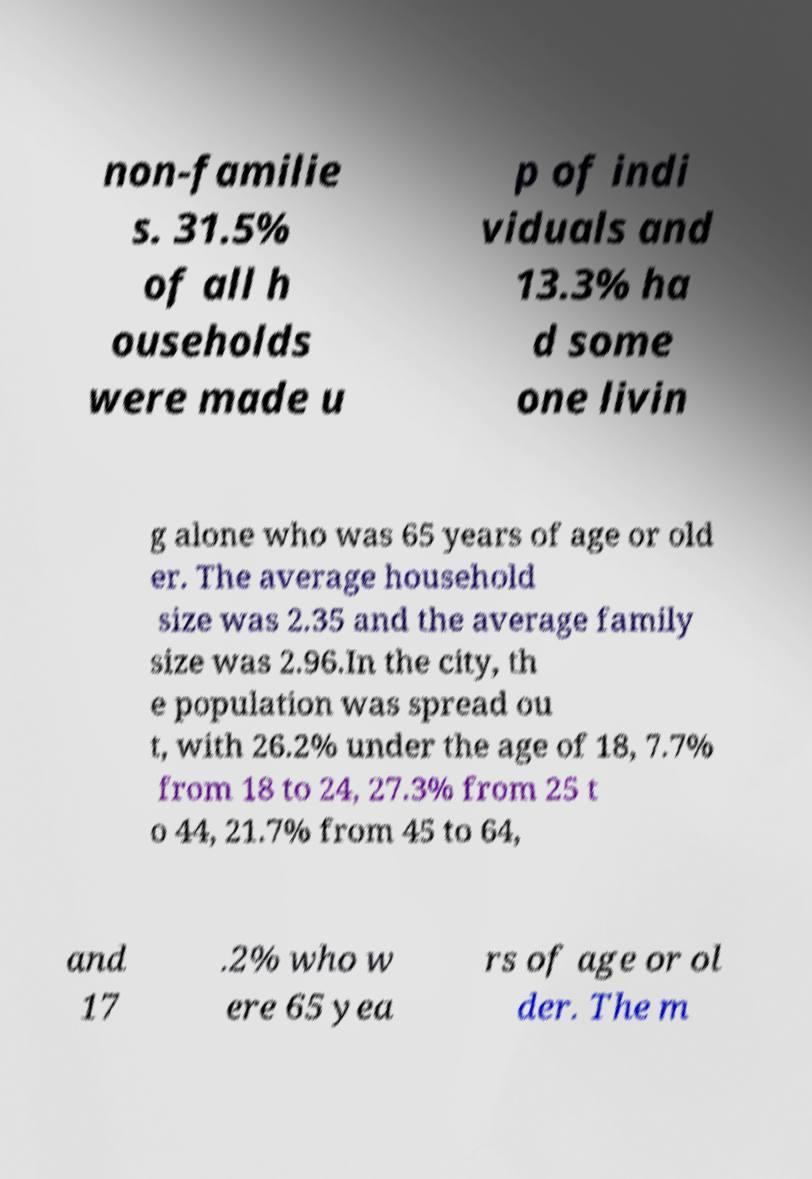I need the written content from this picture converted into text. Can you do that? non-familie s. 31.5% of all h ouseholds were made u p of indi viduals and 13.3% ha d some one livin g alone who was 65 years of age or old er. The average household size was 2.35 and the average family size was 2.96.In the city, th e population was spread ou t, with 26.2% under the age of 18, 7.7% from 18 to 24, 27.3% from 25 t o 44, 21.7% from 45 to 64, and 17 .2% who w ere 65 yea rs of age or ol der. The m 